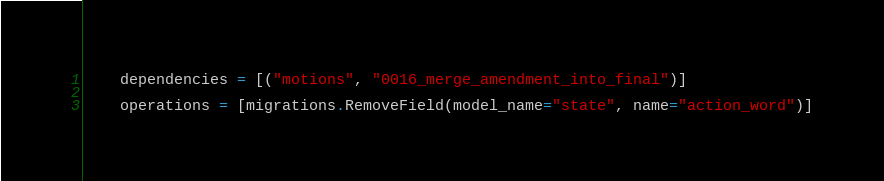<code> <loc_0><loc_0><loc_500><loc_500><_Python_>    dependencies = [("motions", "0016_merge_amendment_into_final")]

    operations = [migrations.RemoveField(model_name="state", name="action_word")]
</code> 